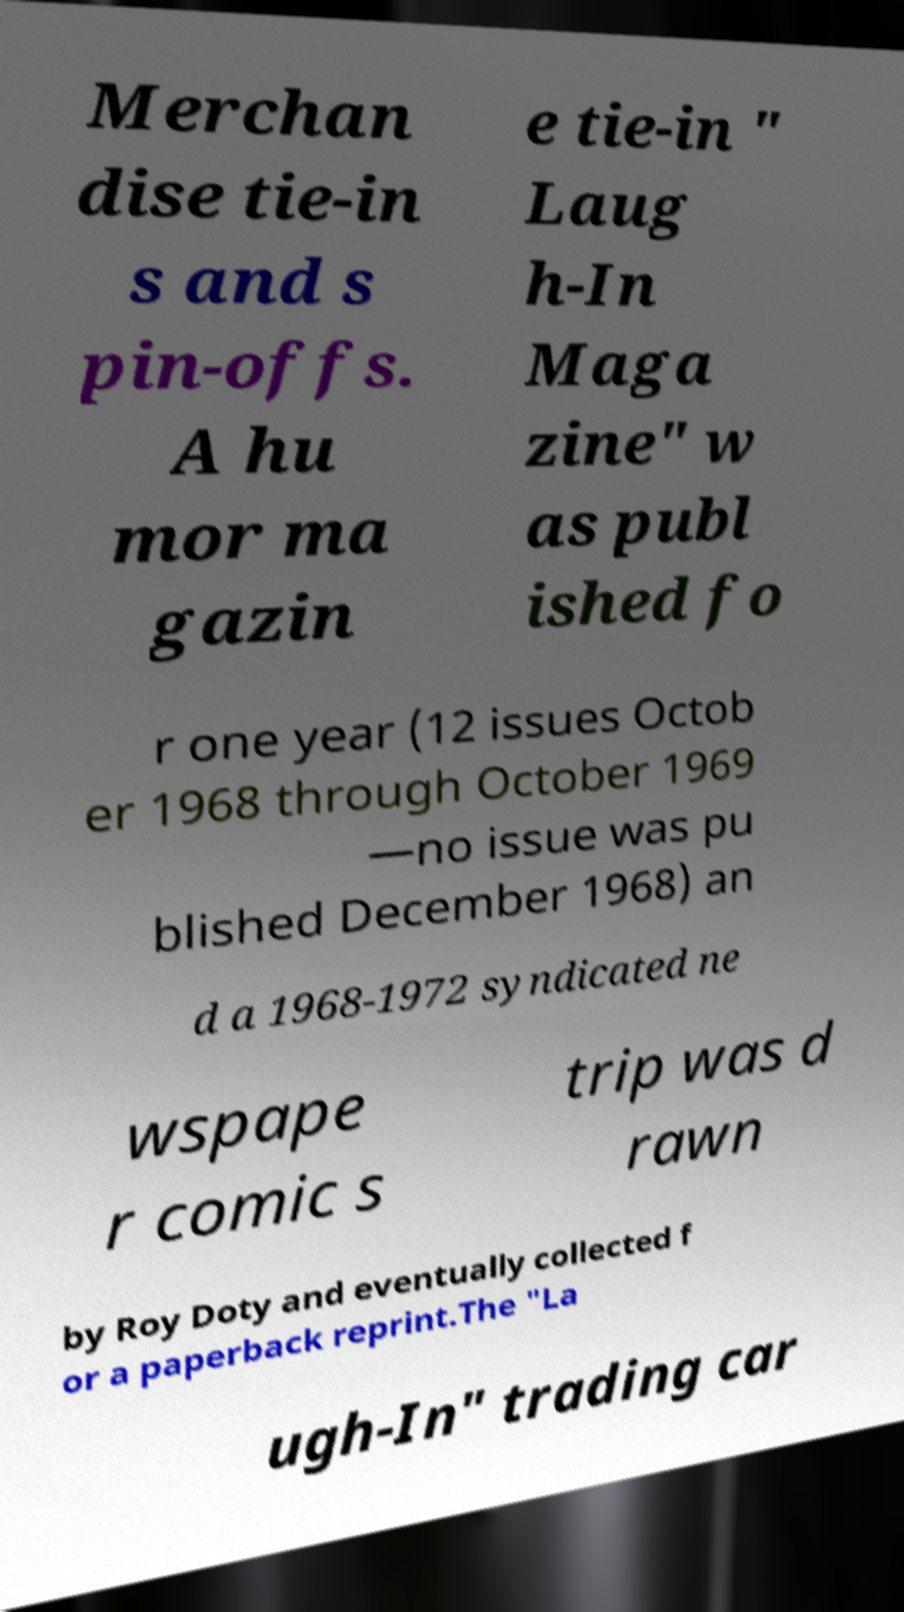Please read and relay the text visible in this image. What does it say? Merchan dise tie-in s and s pin-offs. A hu mor ma gazin e tie-in " Laug h-In Maga zine" w as publ ished fo r one year (12 issues Octob er 1968 through October 1969 —no issue was pu blished December 1968) an d a 1968-1972 syndicated ne wspape r comic s trip was d rawn by Roy Doty and eventually collected f or a paperback reprint.The "La ugh-In" trading car 